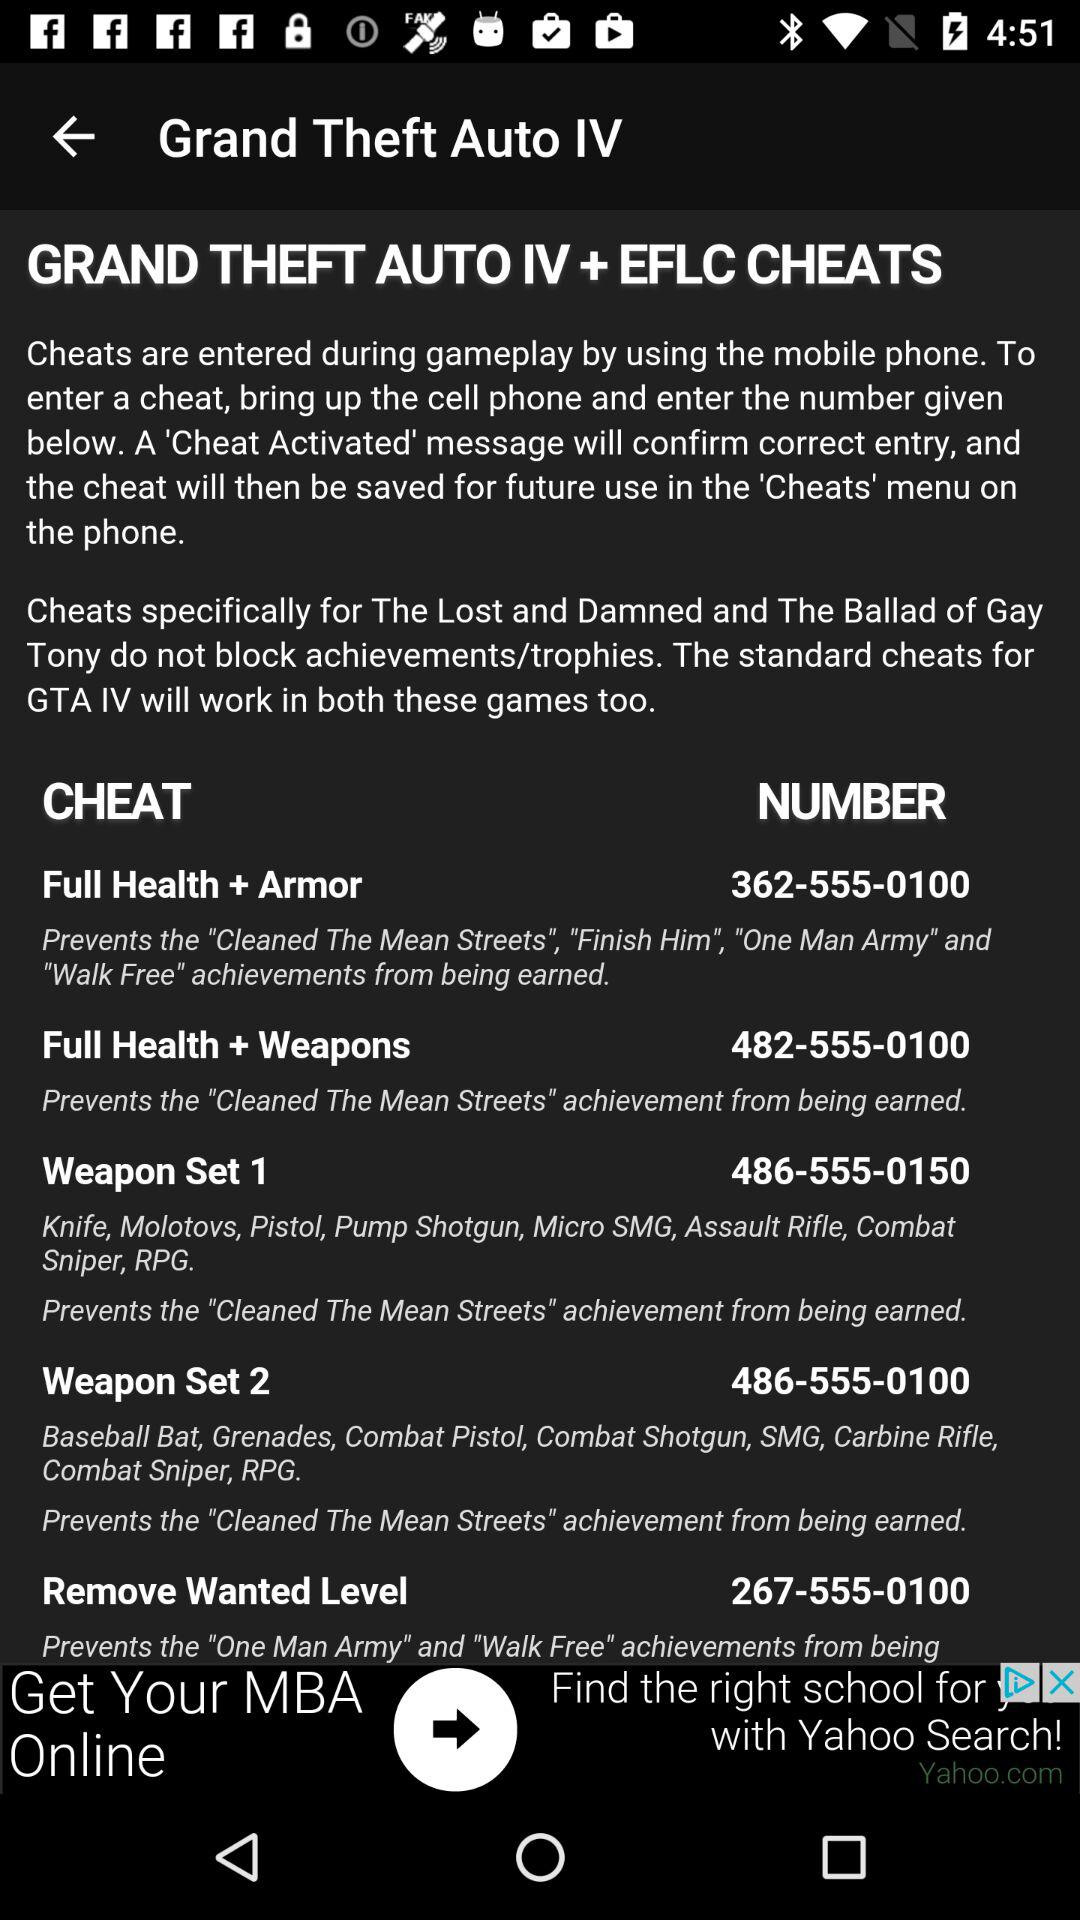Which cheat has the given number 362-555-0100? The cheat is "Full Health + Armor". 